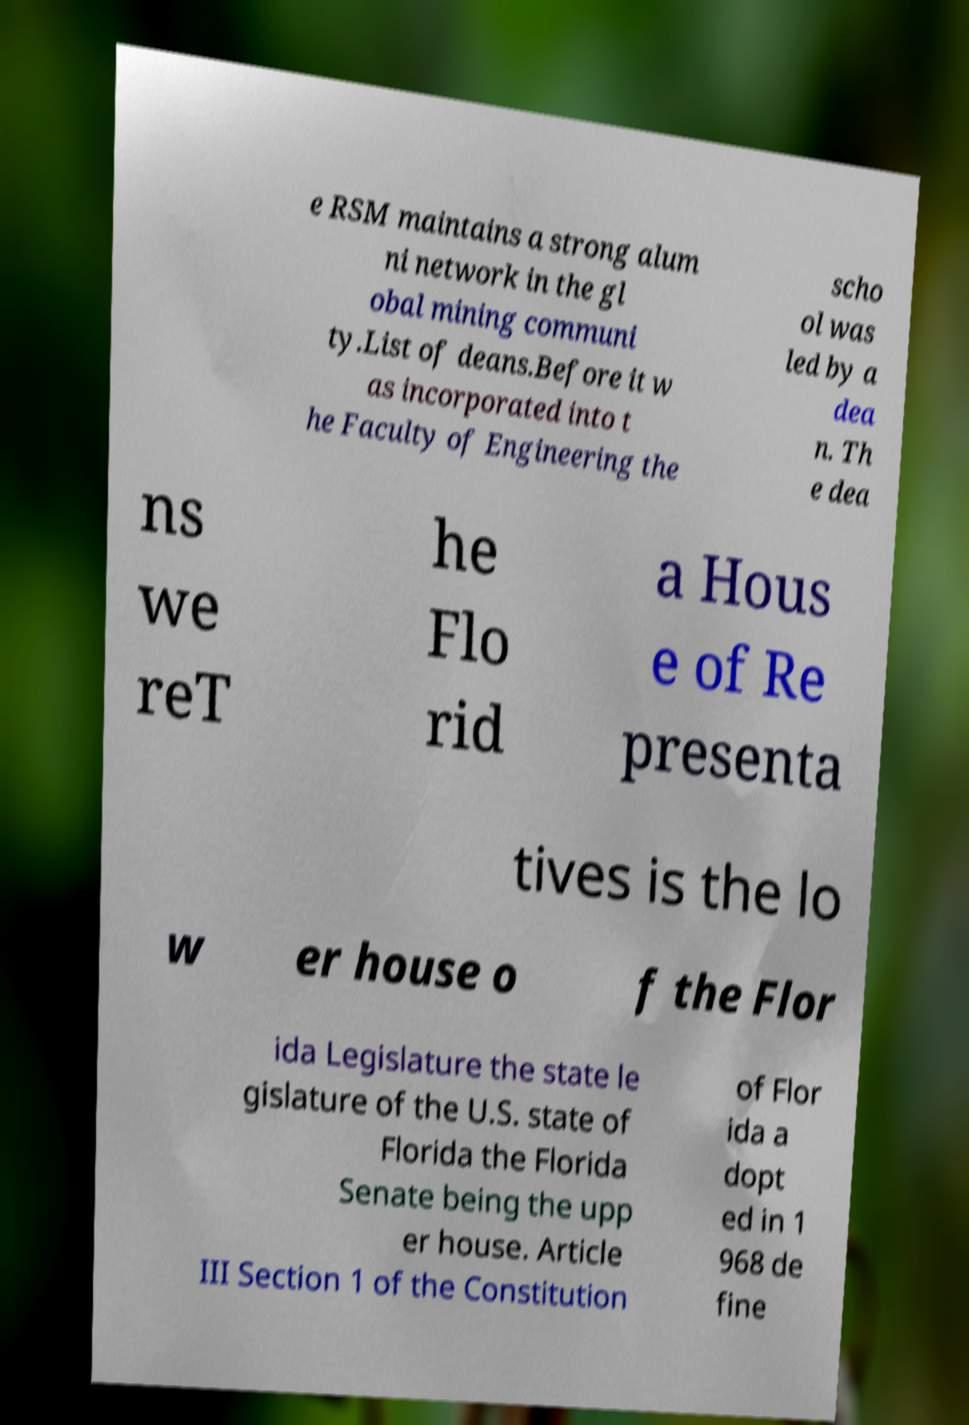Can you read and provide the text displayed in the image?This photo seems to have some interesting text. Can you extract and type it out for me? e RSM maintains a strong alum ni network in the gl obal mining communi ty.List of deans.Before it w as incorporated into t he Faculty of Engineering the scho ol was led by a dea n. Th e dea ns we reT he Flo rid a Hous e of Re presenta tives is the lo w er house o f the Flor ida Legislature the state le gislature of the U.S. state of Florida the Florida Senate being the upp er house. Article III Section 1 of the Constitution of Flor ida a dopt ed in 1 968 de fine 